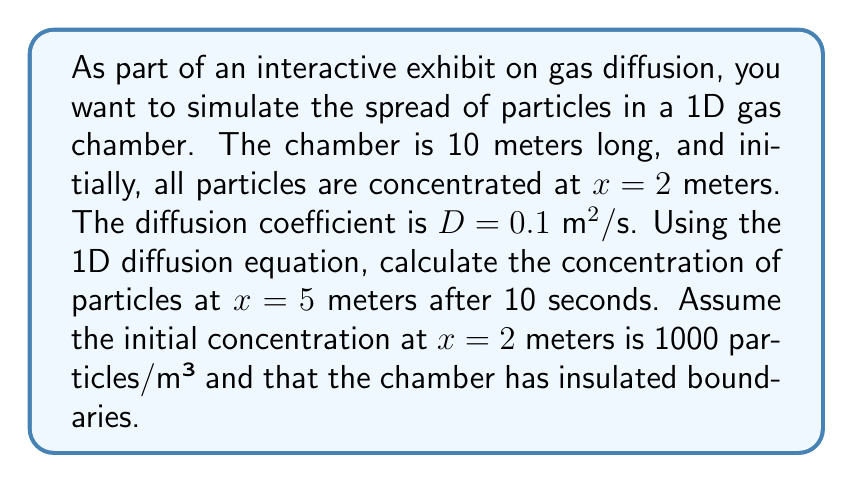Help me with this question. To solve this problem, we'll use the 1D diffusion equation and the method of separation of variables.

1) The 1D diffusion equation is:

   $$\frac{\partial c}{\partial t} = D\frac{\partial^2 c}{\partial x^2}$$

   where $c(x,t)$ is the concentration, $t$ is time, $x$ is position, and $D$ is the diffusion coefficient.

2) Given the initial condition, we can model this as a delta function:

   $$c(x,0) = 1000\delta(x-2)$$

3) For insulated boundaries, we use Neumann boundary conditions:

   $$\frac{\partial c}{\partial x}(0,t) = \frac{\partial c}{\partial x}(10,t) = 0$$

4) The solution to this problem is given by:

   $$c(x,t) = \frac{1000}{10} + \frac{200}{10}\sum_{n=1}^{\infty} \cos\left(\frac{n\pi x}{10}\right) \cos\left(\frac{n\pi 2}{10}\right) e^{-D(n\pi/10)^2t}$$

5) We need to calculate $c(5,10)$. Let's substitute the values:

   $$c(5,10) = 100 + 20\sum_{n=1}^{\infty} \cos\left(\frac{n\pi 5}{10}\right) \cos\left(\frac{n\pi 2}{10}\right) e^{-0.1(n\pi/10)^2 10}$$

6) We can simplify this further:

   $$c(5,10) = 100 + 20\sum_{n=1}^{\infty} (-1)^n \cos\left(\frac{n\pi 2}{10}\right) e^{-0.1n^2\pi^2/10}$$

7) We can compute this sum numerically. After about 10 terms, the sum converges to approximately -4.9735.

8) Therefore, the final concentration is:

   $$c(5,10) \approx 100 + 20(-4.9735) = 0.47 \text{ particles/m}^3$$
Answer: The concentration of particles at x = 5 meters after 10 seconds is approximately 0.47 particles/m³. 